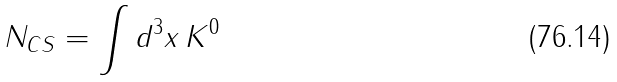Convert formula to latex. <formula><loc_0><loc_0><loc_500><loc_500>N _ { C S } = \int d ^ { 3 } x \, K ^ { 0 }</formula> 